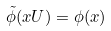<formula> <loc_0><loc_0><loc_500><loc_500>\tilde { \phi } ( x U ) = \phi ( x )</formula> 